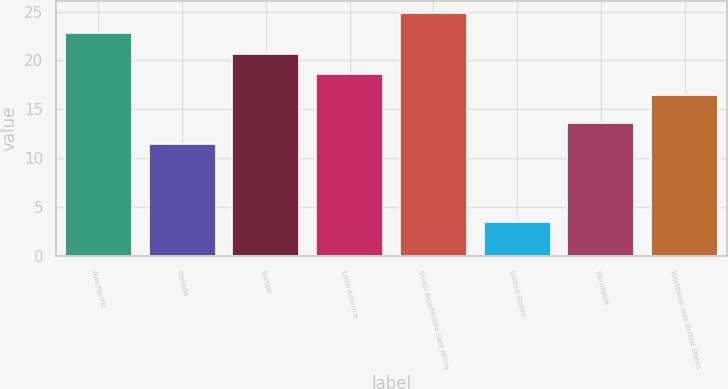Convert chart. <chart><loc_0><loc_0><loc_500><loc_500><bar_chart><fcel>Asia/Pacific<fcel>Canada<fcel>Europe<fcel>Latin America<fcel>South Asia/Middle East Africa<fcel>United States<fcel>Worldwide<fcel>Worldwide less United States<nl><fcel>22.77<fcel>11.5<fcel>20.68<fcel>18.59<fcel>24.86<fcel>3.5<fcel>13.59<fcel>16.5<nl></chart> 